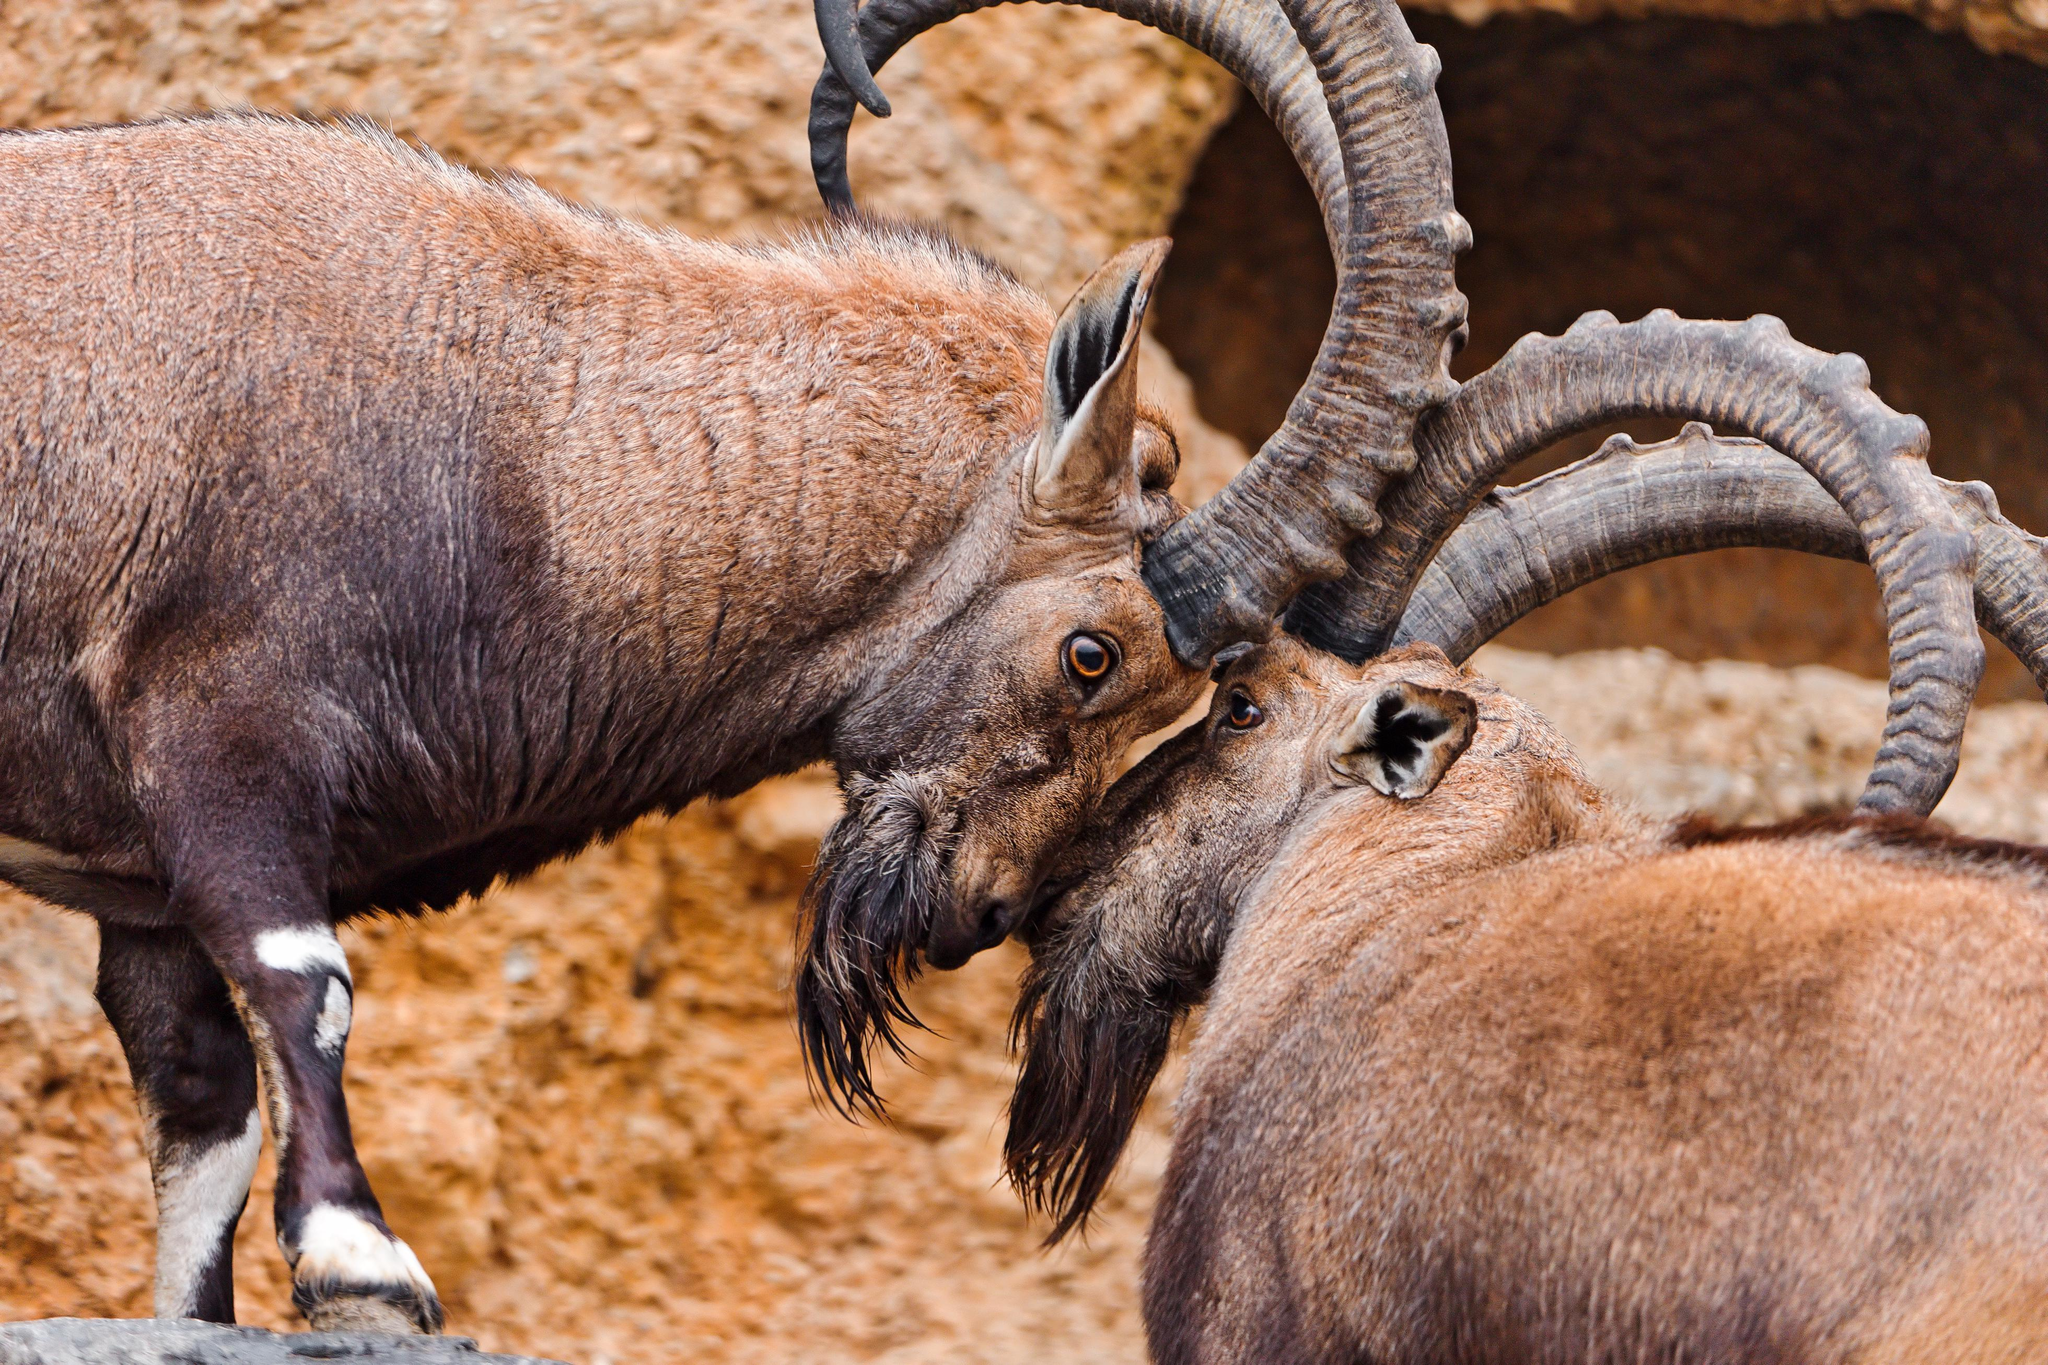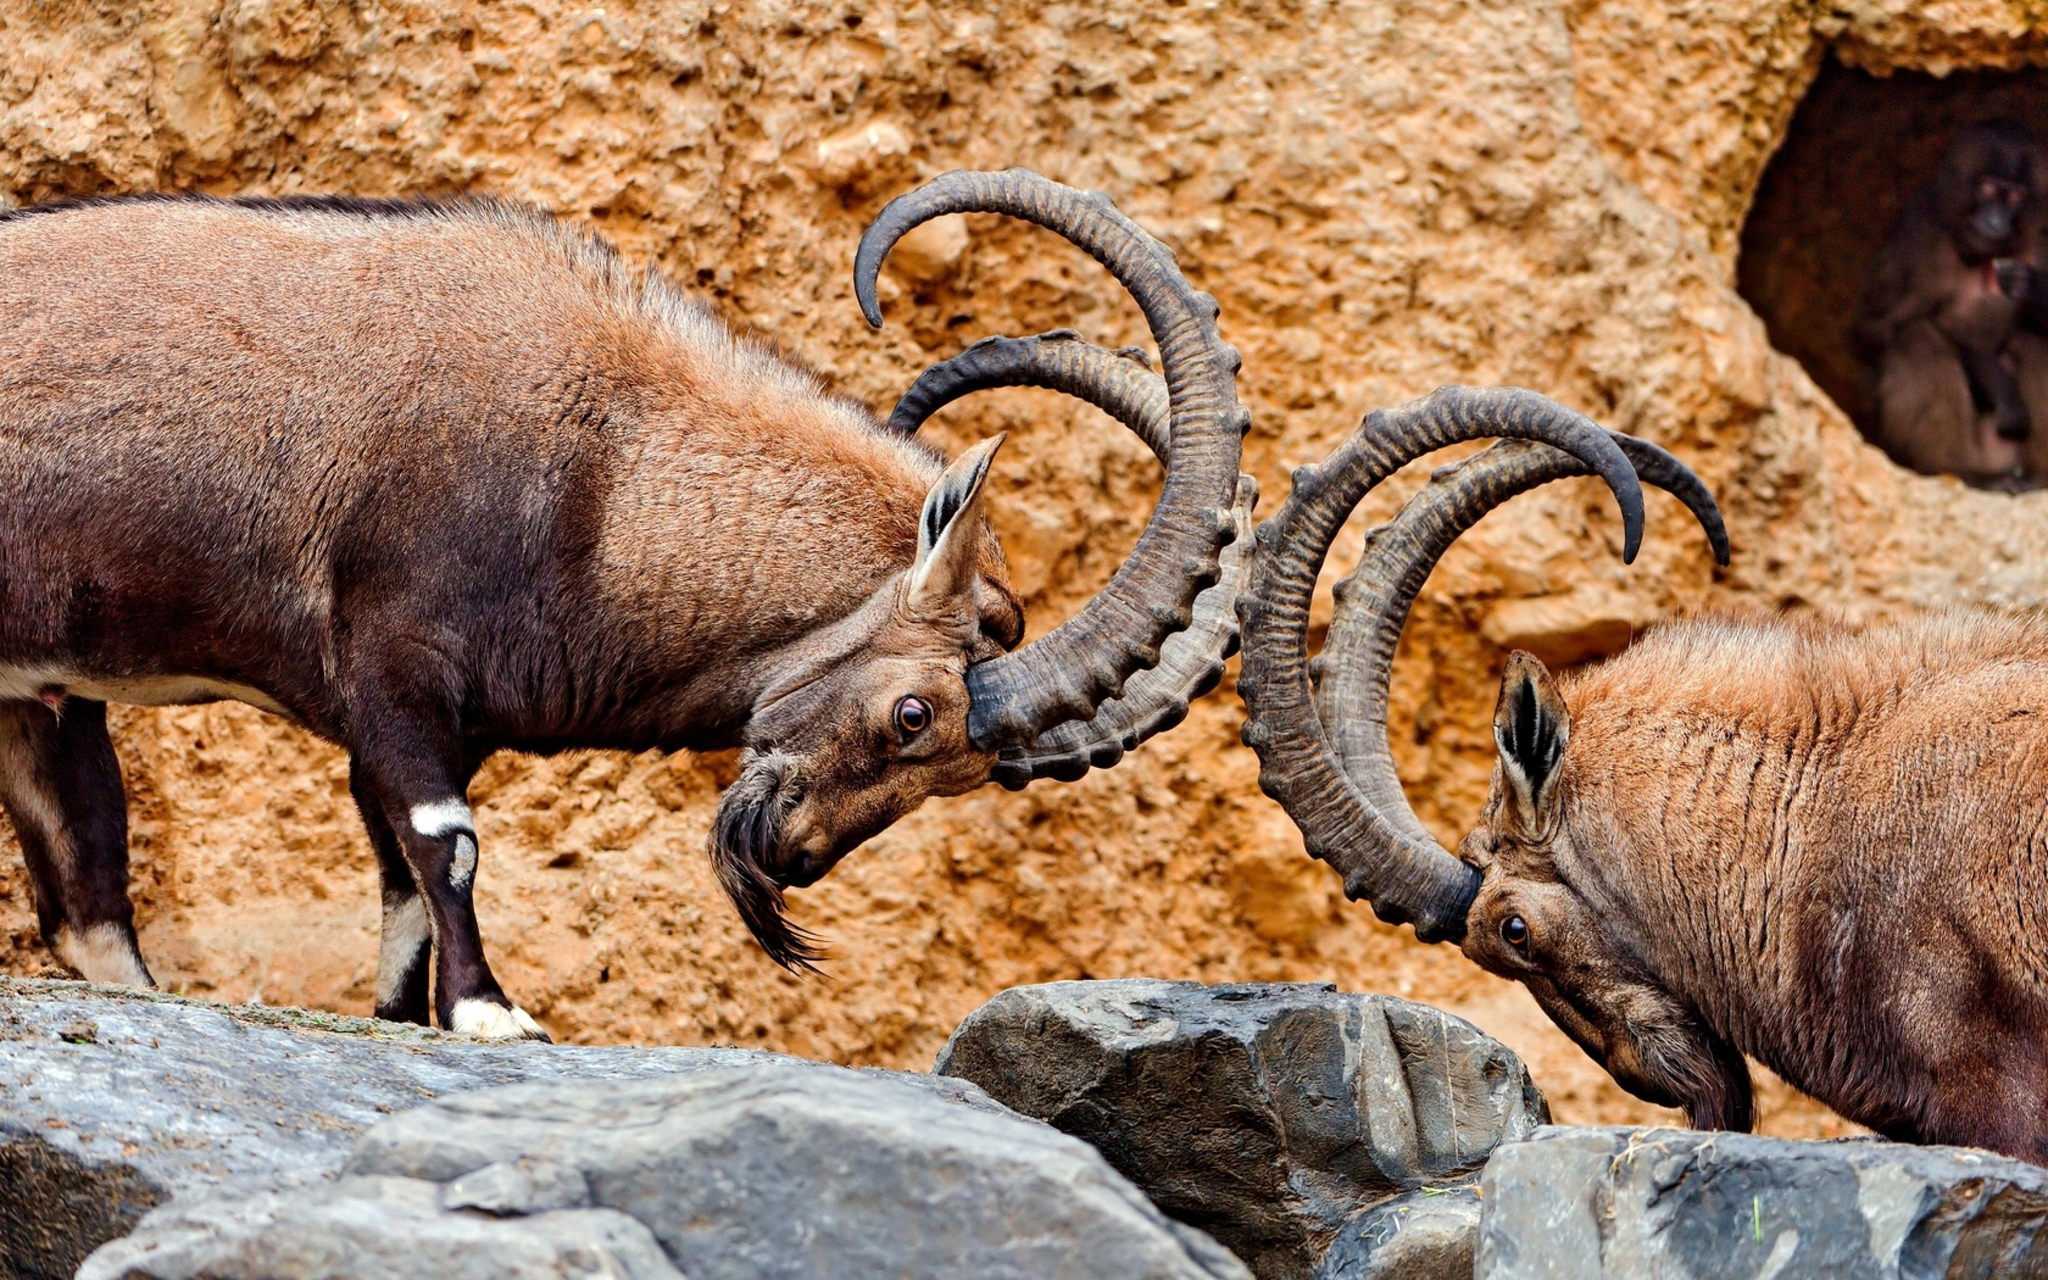The first image is the image on the left, the second image is the image on the right. Assess this claim about the two images: "Two rams are locking horns in each of the images.". Correct or not? Answer yes or no. Yes. 